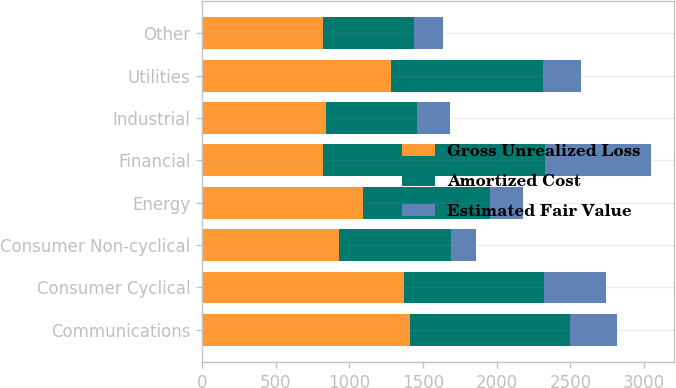Convert chart to OTSL. <chart><loc_0><loc_0><loc_500><loc_500><stacked_bar_chart><ecel><fcel>Communications<fcel>Consumer Cyclical<fcel>Consumer Non-cyclical<fcel>Energy<fcel>Financial<fcel>Industrial<fcel>Utilities<fcel>Other<nl><fcel>Gross Unrealized Loss<fcel>1408<fcel>1372<fcel>928<fcel>1090<fcel>819<fcel>843<fcel>1285<fcel>819<nl><fcel>Amortized Cost<fcel>1088<fcel>947<fcel>761<fcel>867<fcel>1509<fcel>616<fcel>1028<fcel>620<nl><fcel>Estimated Fair Value<fcel>320<fcel>425<fcel>167<fcel>223<fcel>720<fcel>227<fcel>257<fcel>199<nl></chart> 